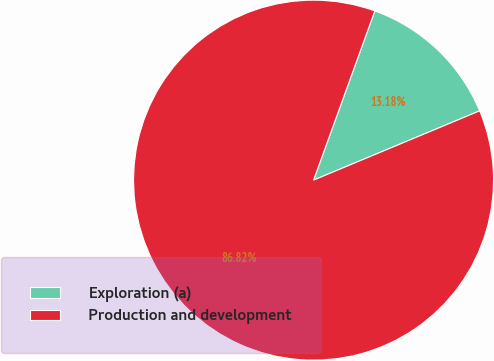<chart> <loc_0><loc_0><loc_500><loc_500><pie_chart><fcel>Exploration (a)<fcel>Production and development<nl><fcel>13.18%<fcel>86.82%<nl></chart> 